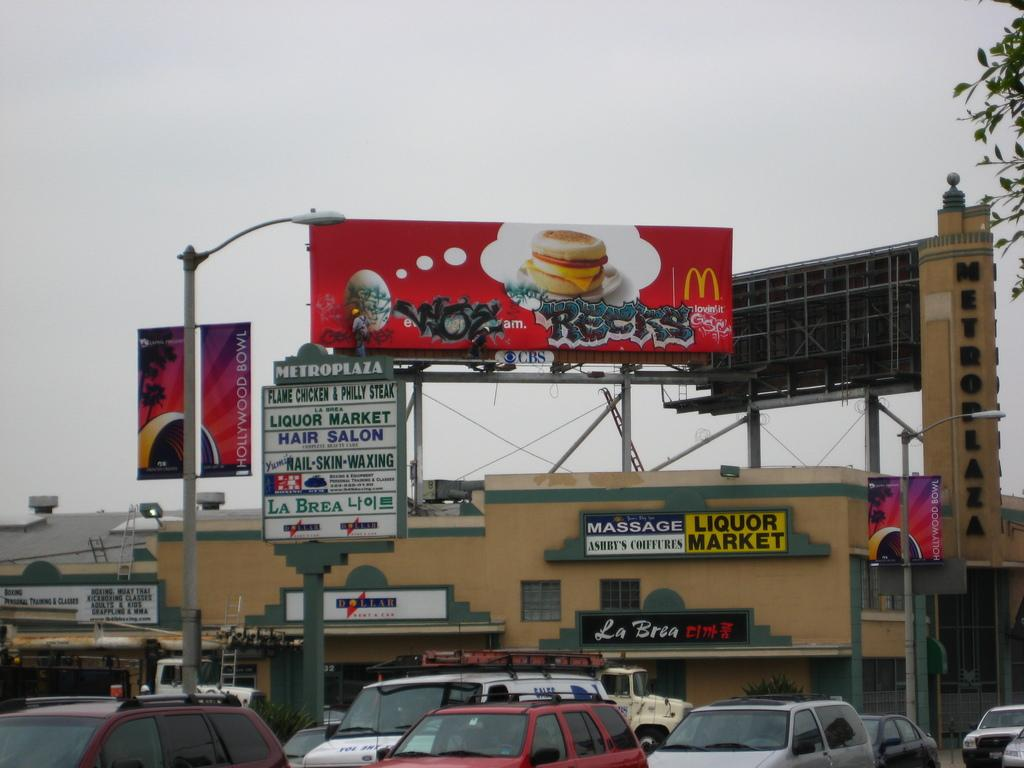<image>
Summarize the visual content of the image. The big red billboard is advertising for Mcdonald's 